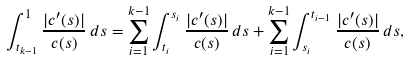<formula> <loc_0><loc_0><loc_500><loc_500>\int _ { t _ { k - 1 } } ^ { 1 } \frac { | c ^ { \prime } ( s ) | } { c ( s ) } \, d s = \sum _ { i = 1 } ^ { k - 1 } \int _ { t _ { i } } ^ { s _ { i } } \frac { | c ^ { \prime } ( s ) | } { c ( s ) } \, d s + \sum _ { i = 1 } ^ { k - 1 } \int _ { s _ { i } } ^ { t _ { i - 1 } } \frac { | c ^ { \prime } ( s ) | } { c ( s ) } \, d s ,</formula> 